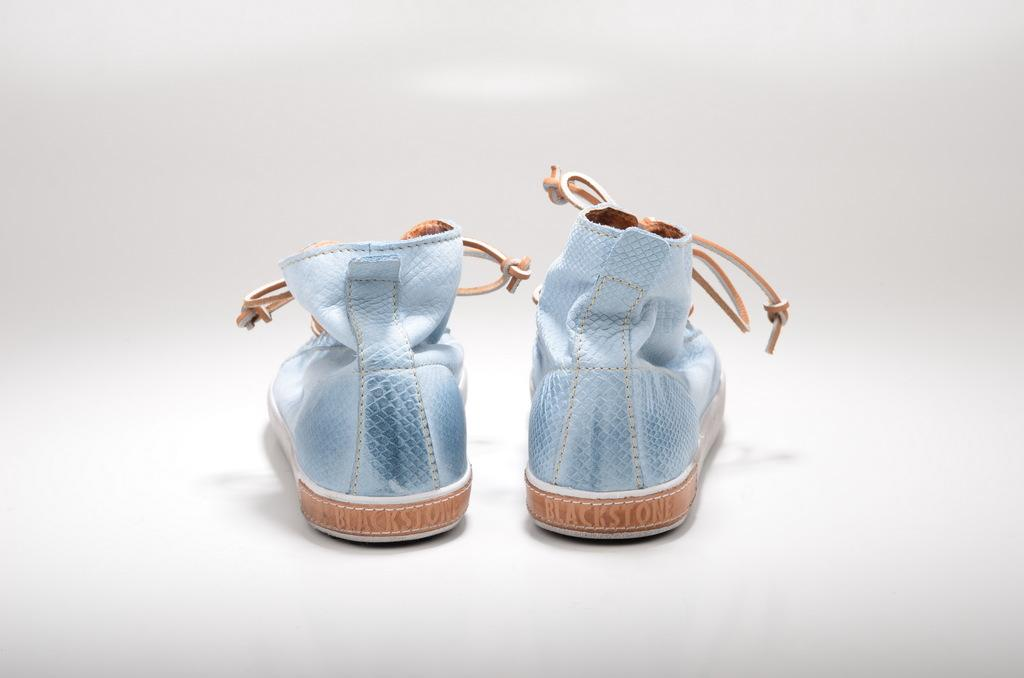What type of object is present on the white surface in the image? There is footwear in the image. Can you describe the surface on which the footwear is placed? The footwear is on a white surface. What is the color of the background in the image? The background of the image is white. Can you see any waves crashing on the shore in the image? There are no waves or shore visible in the image; it features footwear on a white surface with a white background. 